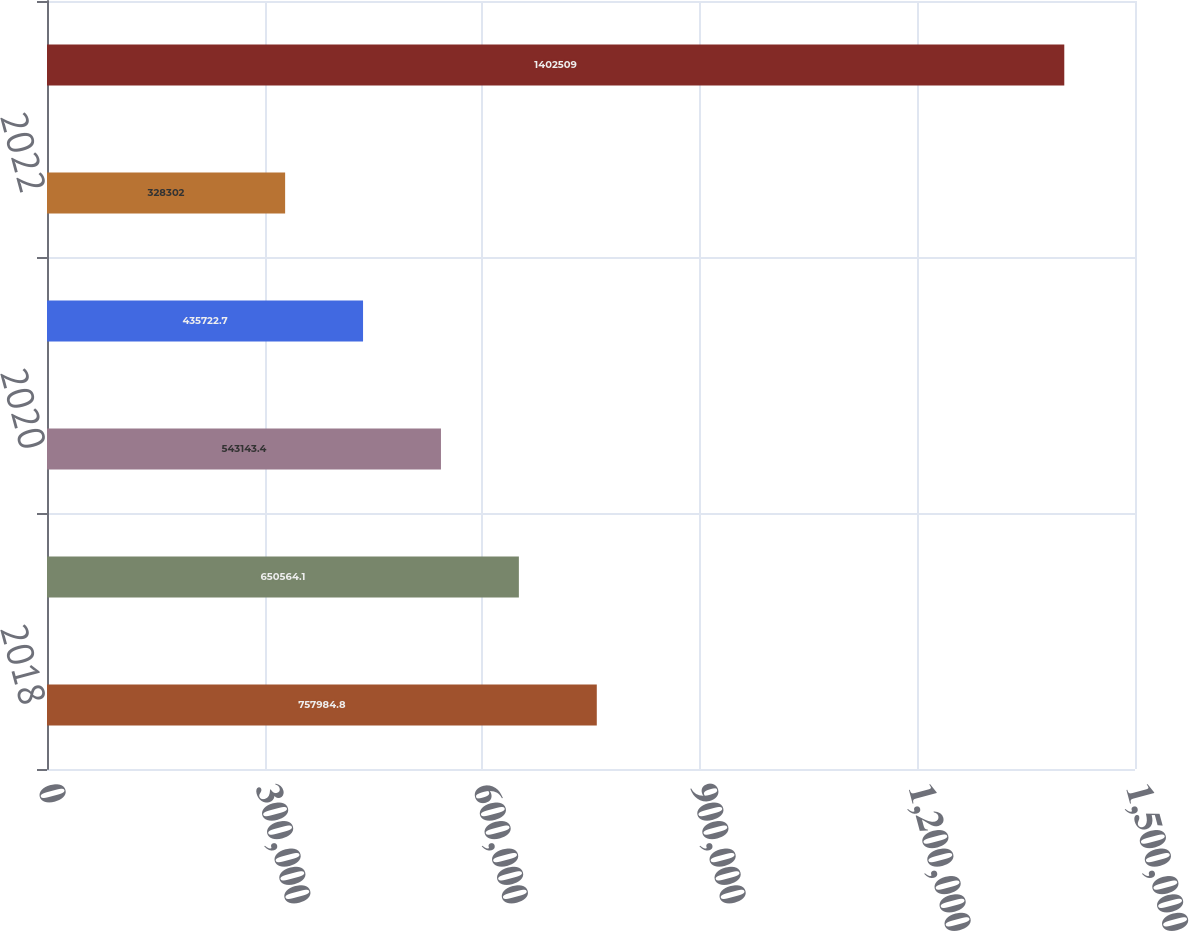Convert chart to OTSL. <chart><loc_0><loc_0><loc_500><loc_500><bar_chart><fcel>2018<fcel>2019<fcel>2020<fcel>2021<fcel>2022<fcel>Thereafter<nl><fcel>757985<fcel>650564<fcel>543143<fcel>435723<fcel>328302<fcel>1.40251e+06<nl></chart> 